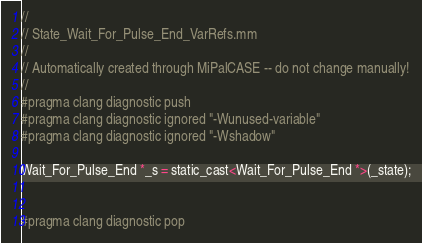<code> <loc_0><loc_0><loc_500><loc_500><_ObjectiveC_>//
// State_Wait_For_Pulse_End_VarRefs.mm
//
// Automatically created through MiPalCASE -- do not change manually!
//
#pragma clang diagnostic push
#pragma clang diagnostic ignored "-Wunused-variable"
#pragma clang diagnostic ignored "-Wshadow"

Wait_For_Pulse_End *_s = static_cast<Wait_For_Pulse_End *>(_state);


#pragma clang diagnostic pop
</code> 